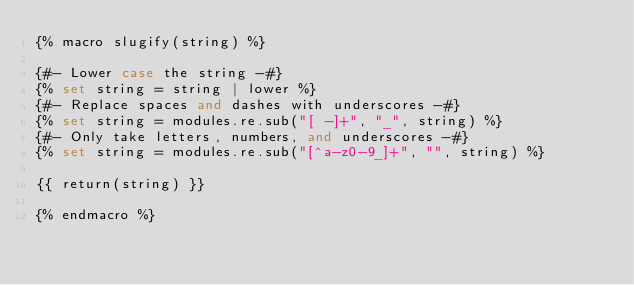<code> <loc_0><loc_0><loc_500><loc_500><_SQL_>{% macro slugify(string) %}

{#- Lower case the string -#}
{% set string = string | lower %}
{#- Replace spaces and dashes with underscores -#}
{% set string = modules.re.sub("[ -]+", "_", string) %}
{#- Only take letters, numbers, and underscores -#}
{% set string = modules.re.sub("[^a-z0-9_]+", "", string) %}

{{ return(string) }}

{% endmacro %}
</code> 